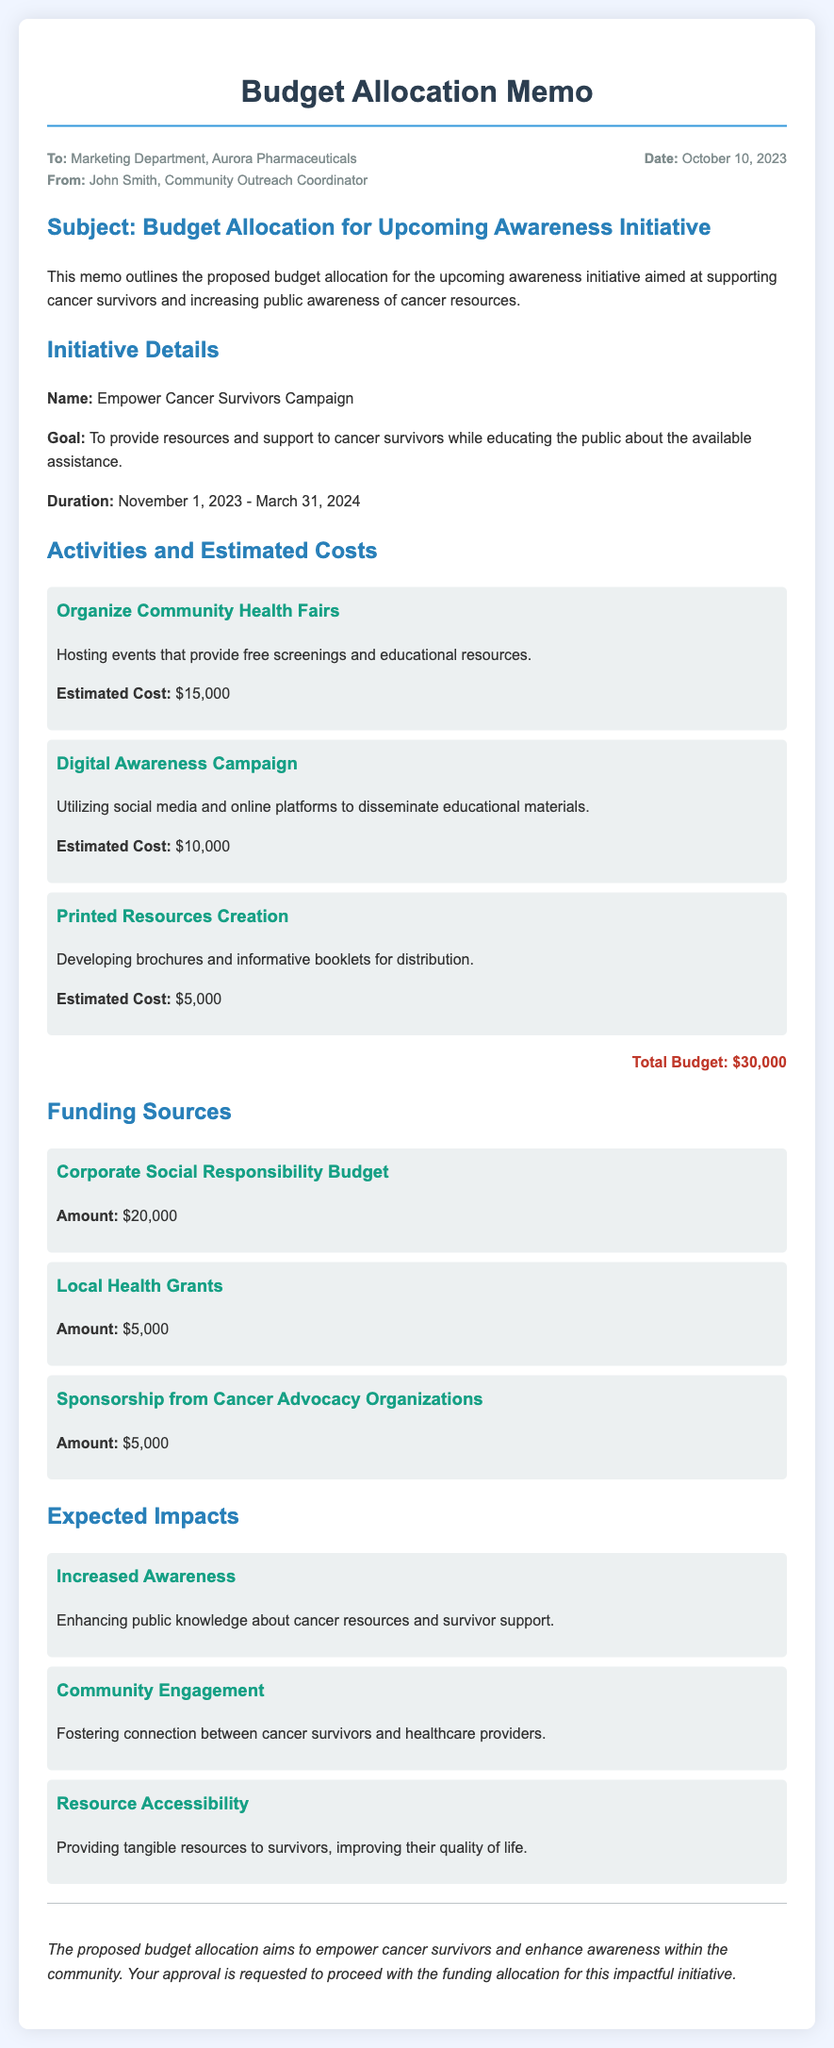What is the total budget for the initiative? The total budget is stated at the end of the "Activities and Estimated Costs" section.
Answer: $30,000 Who is the memo addressed to? The recipient is mentioned in the meta section of the memo, where "To" is specified.
Answer: Marketing Department, Aurora Pharmaceuticals When does the initiative start? The start date is outlined in the "Initiative Details" section under "Duration."
Answer: November 1, 2023 What are the funding sources mentioned? The funding sources are listed in the "Funding Sources" section.
Answer: Corporate Social Responsibility Budget, Local Health Grants, Sponsorship from Cancer Advocacy Organizations What is the goal of the campaign? The goal is provided in the "Initiative Details" section, directly after the campaign name.
Answer: To provide resources and support to cancer survivors while educating the public about the available assistance How long is the initiative planned to last? The duration is specifically mentioned in the "Initiative Details" section.
Answer: Until March 31, 2024 What is one expected impact of the initiative? The expected impacts are outlined in the "Expected Impacts" section, with examples given.
Answer: Increased Awareness What is the estimated cost of organizing community health fairs? The estimated cost is detailed under the "Activities and Estimated Costs" section for that specific activity.
Answer: $15,000 Who is the memo from? The sender is mentioned in the meta section of the memo under "From."
Answer: John Smith, Community Outreach Coordinator 